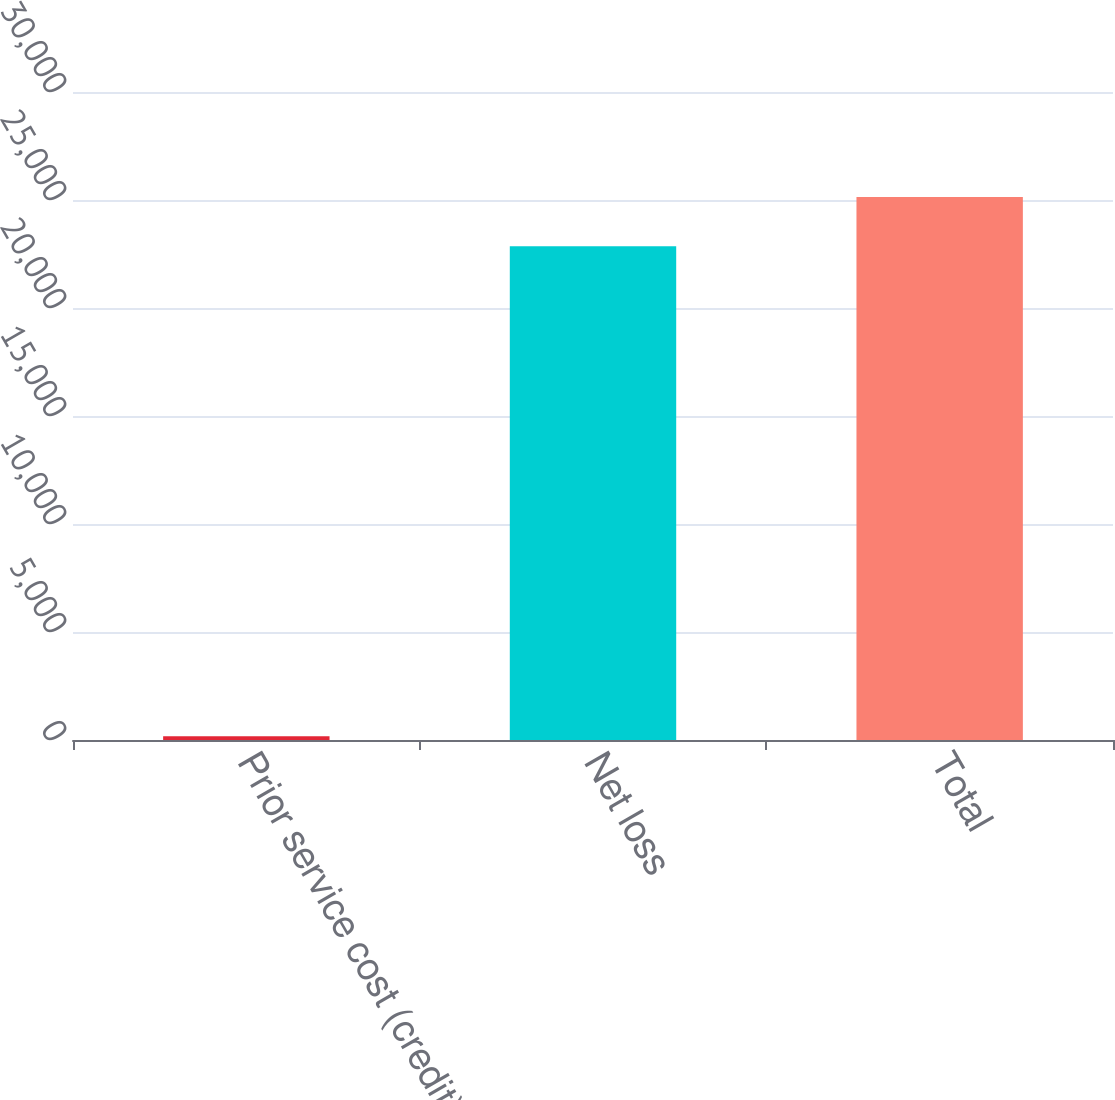Convert chart to OTSL. <chart><loc_0><loc_0><loc_500><loc_500><bar_chart><fcel>Prior service cost (credit)<fcel>Net loss<fcel>Total<nl><fcel>170<fcel>22854<fcel>25139.4<nl></chart> 